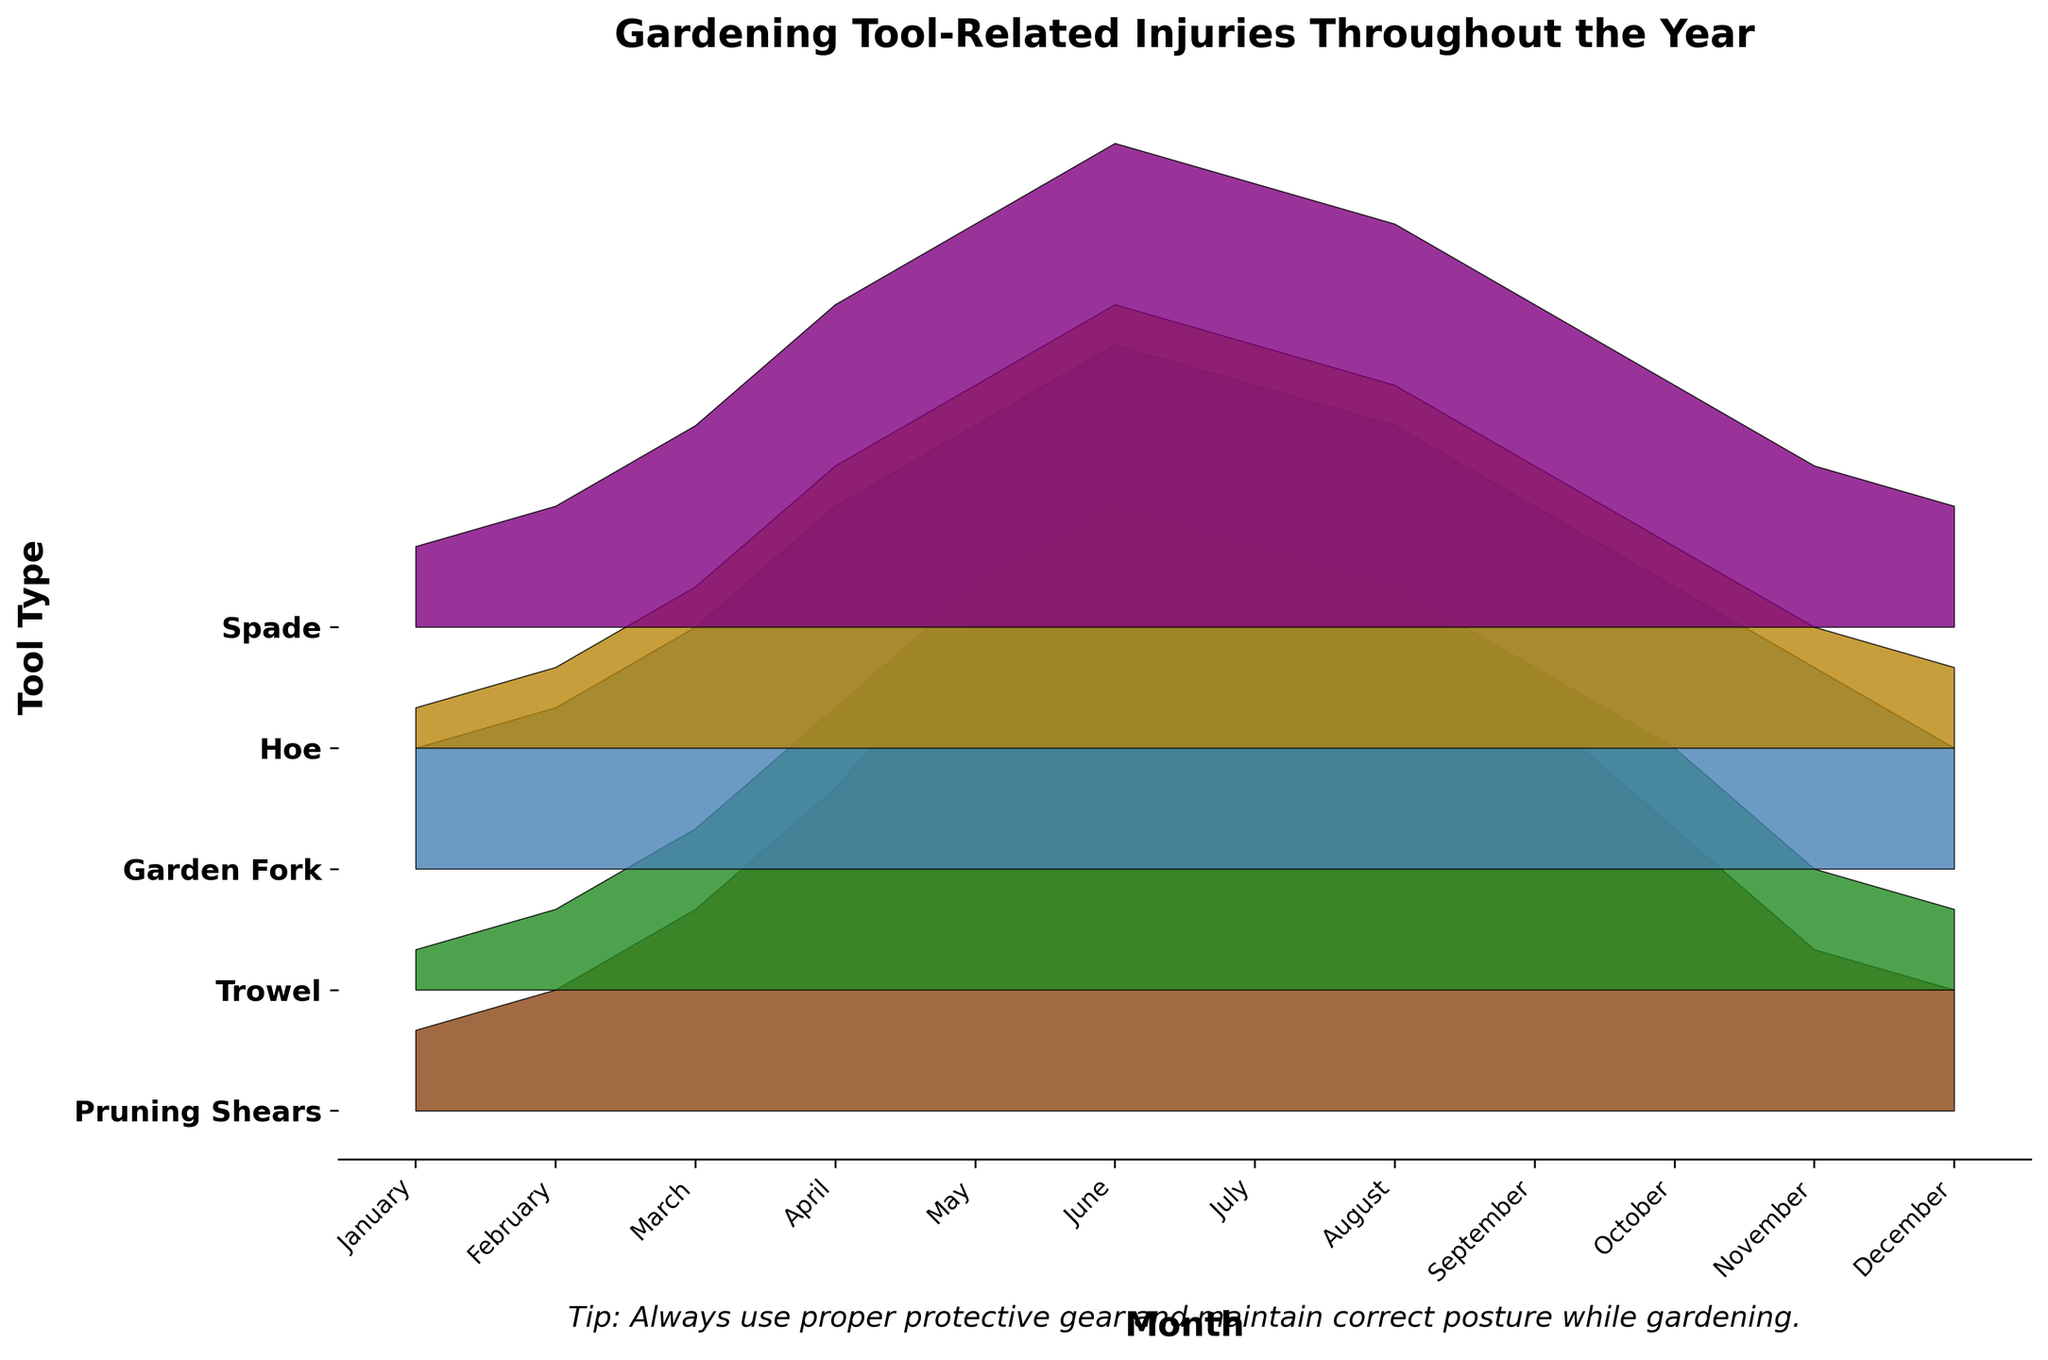What's the title of the plot? The title is a text positioned at the top of the plot, and in this case, it reads: "Gardening Tool-Related Injuries Throughout the Year."
Answer: Gardening Tool-Related Injuries Throughout the Year Which gardening tool sees the highest number of injuries in April? From the figure, the height of the filled area under "April" is highest for the "Garden Fork" indicating it has the highest number of injuries for that month.
Answer: Garden Fork What is the total number of injuries for the Hoe tool over the whole year? To find the total, add the number of injuries for Hoe for each month. Sum = 1 (Jan) + 2 (Feb) + 4 (Mar) + 7 (Apr) + 9 (May) + 11 (Jun) + 10 (Jul) + 9 (Aug) + 7 (Sep) + 5 (Oct) + 3 (Nov) + 2 (Dec) = 70.
Answer: 70 Which months have the same number of injuries for the Pruning Shears tool? By checking the plot, the months that show the same height for "Pruning Shears" are February and December, each having 3 injuries.
Answer: February and December How do the injuries for the Trowel tool in June compare to those in July? In the plot, the filled area for "Trowel" is higher in June (12 injuries) than in July (11 injuries), suggesting a decrease.
Answer: Trowel injuries are higher in June Which tool shows a peak in injuries during the mid-year months (May to August)? When observing the plot from May to August, "Hoe" has consistently high injuries, peaking in June and staying relatively high.
Answer: Hoe What trend is observed for injuries related to the Spade tool throughout the year? The injuries for the Spade tool increase monthly until June, then start decreasing post-June.
Answer: Increase until June, then decrease Sum the injuries for the Garden Fork, Pruning Shears, and Spade tools in March. Sum the March injuries for each tool: Garden Fork (6), Pruning Shears (5), and Spade (5). Sum = 6 + 5 + 5 = 16.
Answer: 16 Are there any tools with an equal number of injuries in two consecutive months? By checking the adjacent months, "Hoe" shows equal injuries in August and September (9 injuries each).
Answer: Yes, Hoe in August and September 